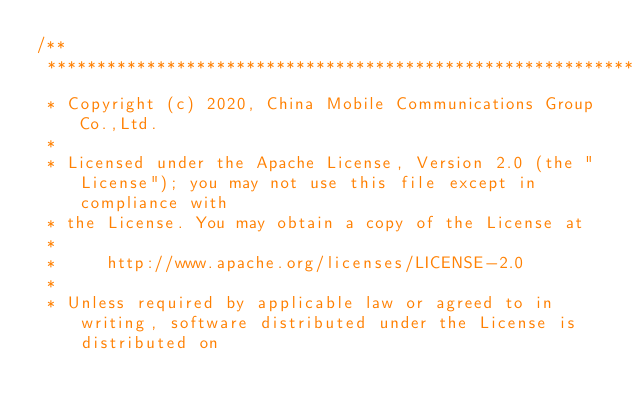<code> <loc_0><loc_0><loc_500><loc_500><_C_>/**
 ***********************************************************************************************************************
 * Copyright (c) 2020, China Mobile Communications Group Co.,Ltd.
 *
 * Licensed under the Apache License, Version 2.0 (the "License"); you may not use this file except in compliance with 
 * the License. You may obtain a copy of the License at
 *
 *     http://www.apache.org/licenses/LICENSE-2.0
 *
 * Unless required by applicable law or agreed to in writing, software distributed under the License is distributed on</code> 